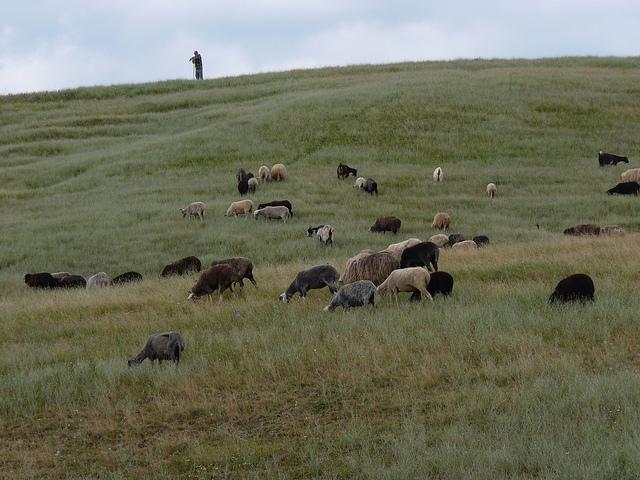How many umbrellas are there?
Give a very brief answer. 0. 